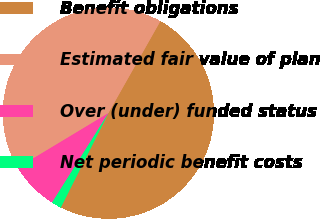Convert chart to OTSL. <chart><loc_0><loc_0><loc_500><loc_500><pie_chart><fcel>Benefit obligations<fcel>Estimated fair value of plan<fcel>Over (under) funded status<fcel>Net periodic benefit costs<nl><fcel>49.25%<fcel>41.82%<fcel>7.43%<fcel>1.51%<nl></chart> 